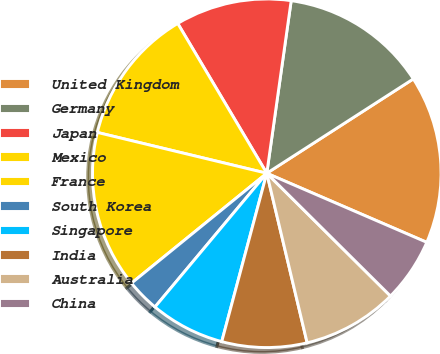<chart> <loc_0><loc_0><loc_500><loc_500><pie_chart><fcel>United Kingdom<fcel>Germany<fcel>Japan<fcel>Mexico<fcel>France<fcel>South Korea<fcel>Singapore<fcel>India<fcel>Australia<fcel>China<nl><fcel>15.59%<fcel>13.66%<fcel>10.77%<fcel>12.7%<fcel>14.62%<fcel>3.06%<fcel>6.92%<fcel>7.88%<fcel>8.84%<fcel>5.95%<nl></chart> 